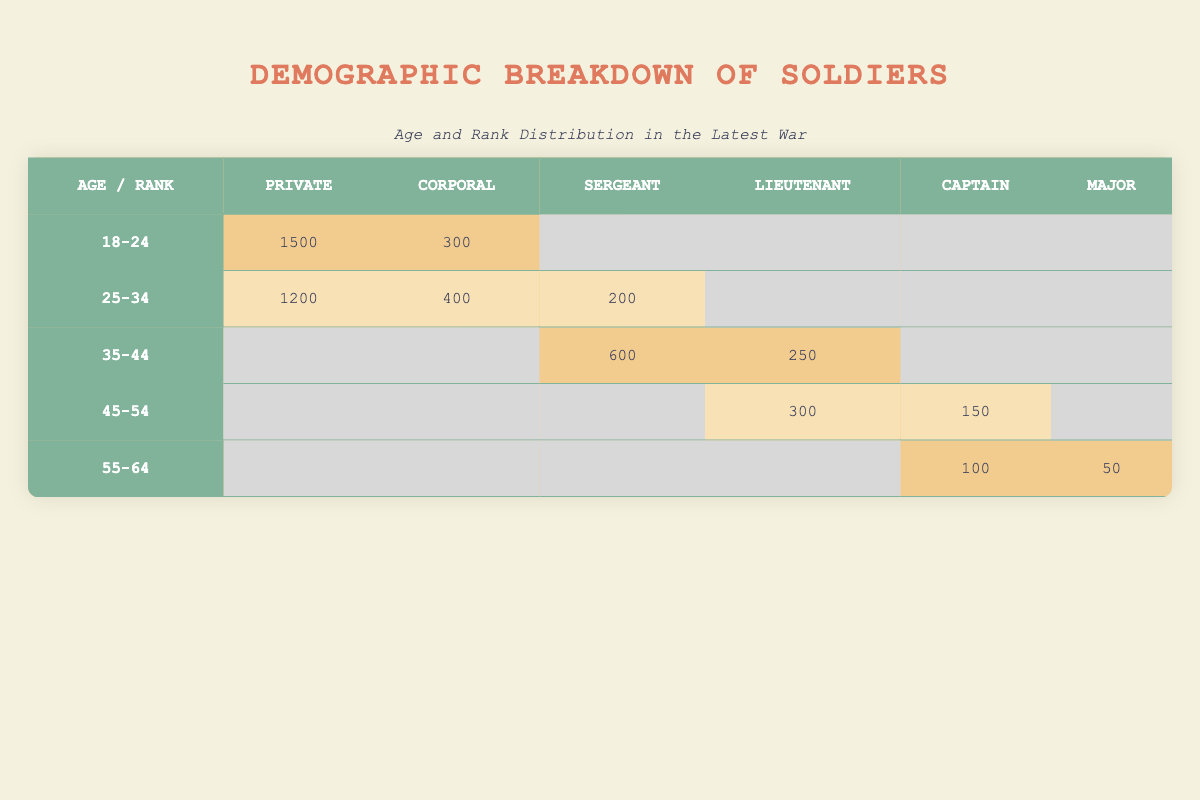What is the total number of soldiers aged 25-34? To find the total number of soldiers aged 25-34, we look at the row for that age group in the table. We see there are 1200 Privates, 400 Corporals, and 200 Sergeants. Adding these values gives us 1200 + 400 + 200 = 1800.
Answer: 1800 How many Lieutenants are there in the age group 35-44? In the row for the age group 35-44, we find that there are 250 Lieutenants. This value is directly taken from the table.
Answer: 250 Are there any Sergeants in the age group 18-24? In the row for the age group 18-24, there is no entry under the Sergeant rank, as it displays an empty cell. Thus, there are no Sergeants in this age group.
Answer: No What is the combined total of Privates across all age groups? We will sum the counts of Privates from each age group: 1500 from age 18-24, 1200 from age 25-34, and 0 from the others (since there are no Privates in age groups 35-44, 45-54, or 55-64). Therefore, the total is 1500 + 1200 + 0 + 0 + 0 = 2700.
Answer: 2700 What is the rank with the least number of soldiers aged 55-64? In the age group 55-64, the table shows 100 Captains and 50 Majors. To find the least, we compare these two values and see that 50 (Majors) is less than 100 (Captains). Therefore, the rank with the least number of soldiers aged 55-64 is Major.
Answer: Major What is the difference in the number of Corporals between the age groups 18-24 and 25-34? The table indicates there are 300 Corporals in the 18-24 age group and 400 in the 25-34 age group. To find the difference, we subtract the lower value from the higher: 400 - 300 = 100.
Answer: 100 How many soldiers are there in total aged 45-54? We add the counts for this age group: there are 300 Lieutenants and 150 Captains for a total of 300 + 150 = 450.
Answer: 450 Is the number of Sergeants greater than that of Captains in the 45-54 age group? In the 45-54 age group, there are 0 Sergeants and 150 Captains. Since 0 is not greater than 150, the statement is false.
Answer: No What age group has the highest number of Corporals? Looking at the table, we see that the highest number of Corporals is in the age group 25-34 with 400 Corporals, as the 18-24 age group has only 300 Corporals. This is determined by comparing the values in their respective rows.
Answer: 25-34 